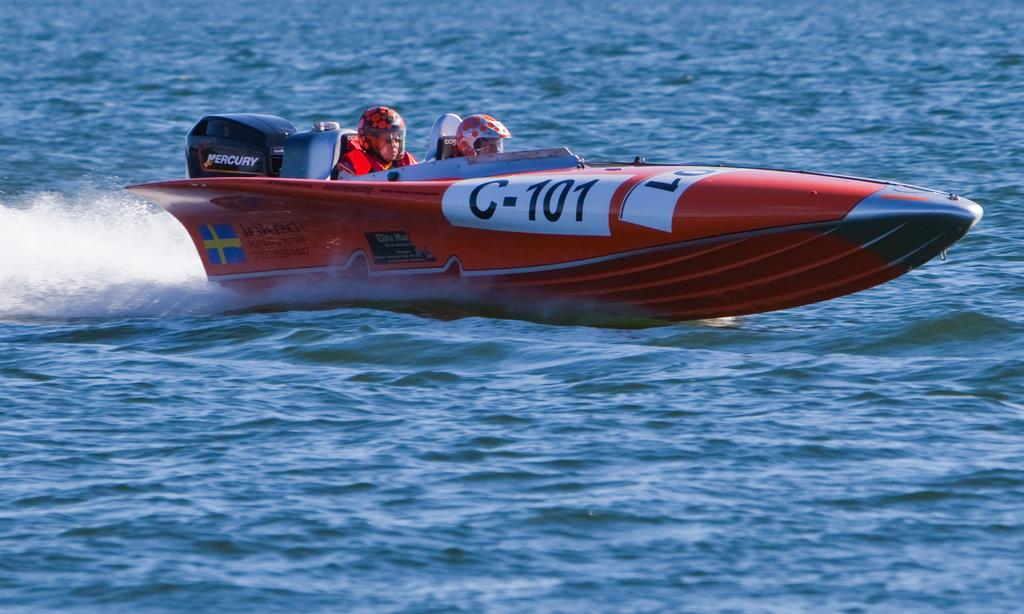How many people are in the image? There are two persons in the image. What are the persons doing in the image? The persons are riding a boat. What safety equipment are the persons wearing? The persons are wearing life jackets and helmets. What can be observed about the water in the image? There is flow in the water. What type of toe nail polish is the person wearing on their left foot in the image? There is no information about toe nail polish or feet in the image, as the persons are wearing life jackets and helmets. 